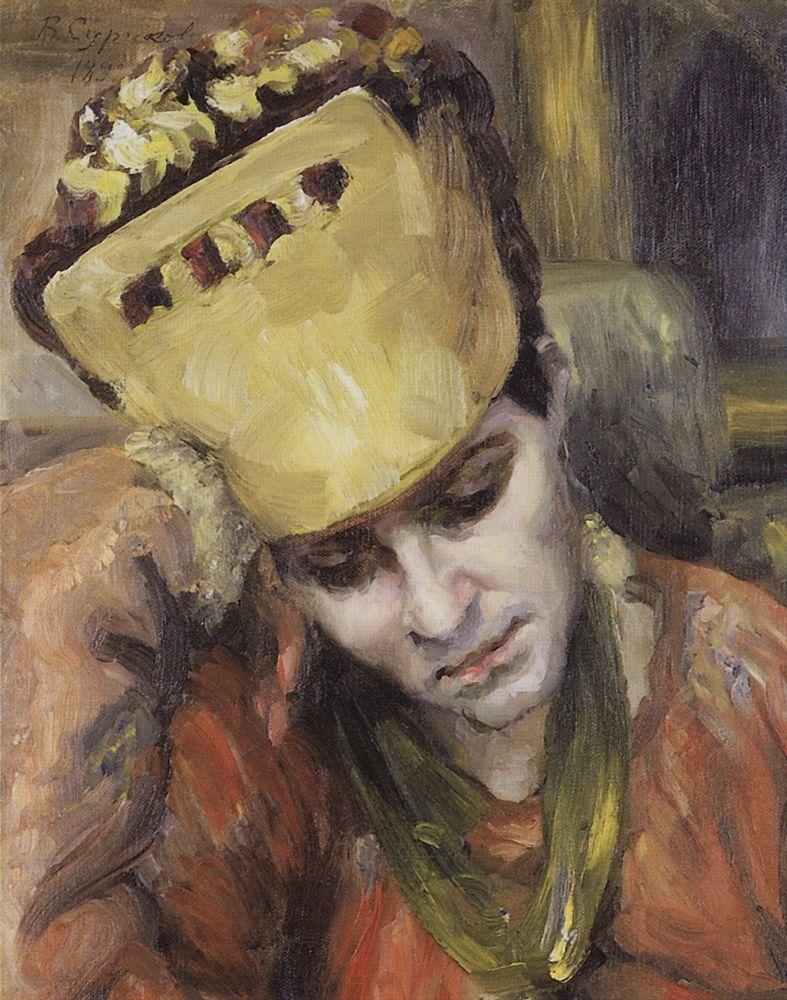Can you tell me what this painting could be representing? This painting likely represents a moment of quiet reflection or introspection. The young woman seems lost in thought, perhaps contemplating her life, dreams, or personal experiences. The use of warm colors and the soft, indistinct background help convey a sense of calm and introspection, suggesting that the artist intended to capture the inner world of the subject. 